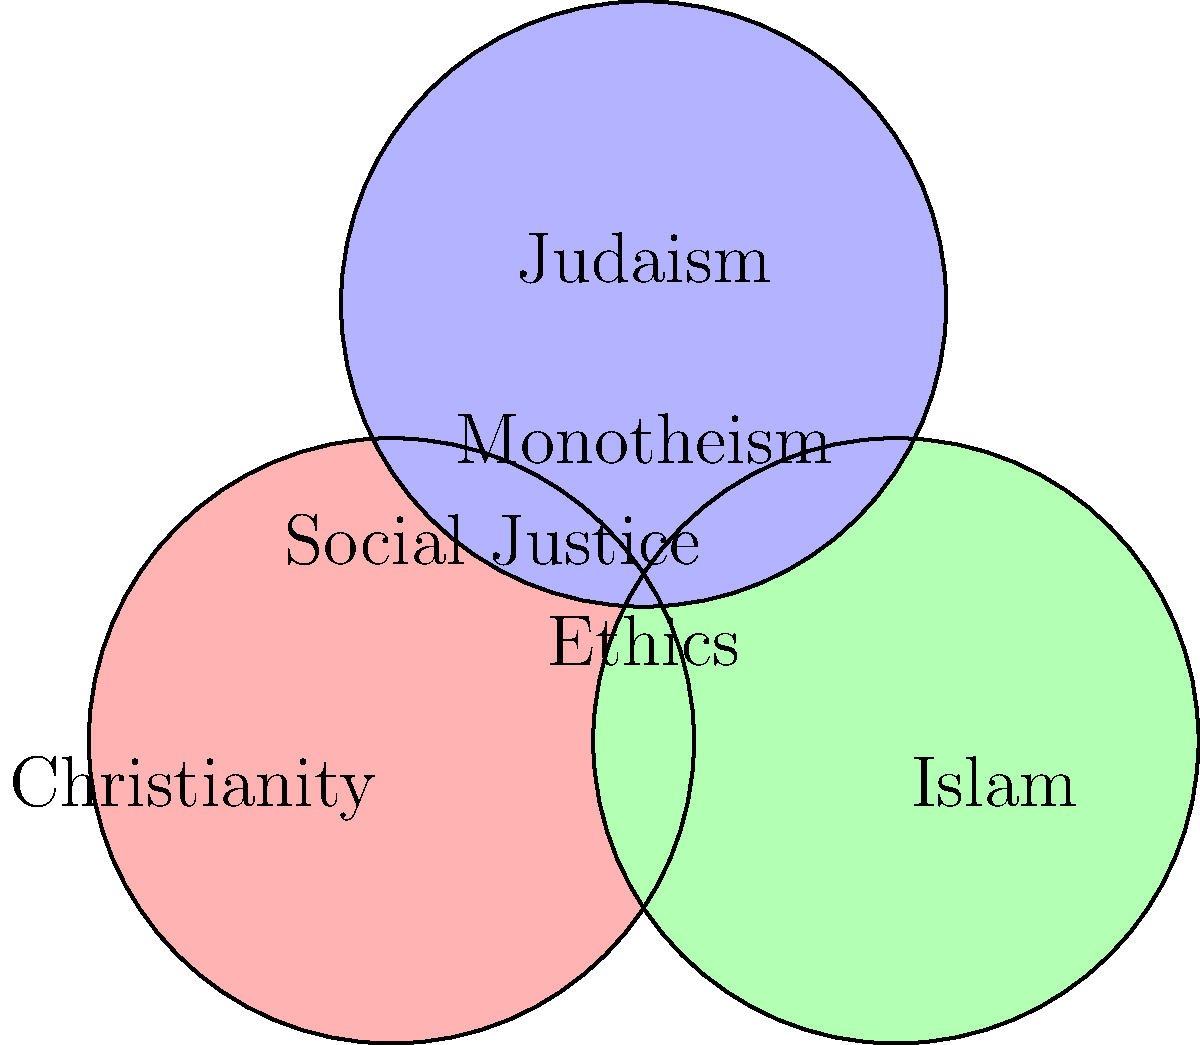In the Venn diagram representing the intersection of Christianity, Islam, and Judaism, which concept is placed at the center, suggesting it is common to all three religions? To answer this question, we need to analyze the Venn diagram step by step:

1. The diagram shows three overlapping circles, each representing one of the three Abrahamic religions: Christianity, Islam, and Judaism.

2. Each circle is labeled with the name of the religion it represents.

3. In the areas where the circles overlap, we can see various concepts that are shared between two or more religions.

4. The area where all three circles intersect represents concepts that are common to all three religions.

5. In this central area, we can see the word "Monotheism" written.

6. Monotheism, the belief in one God, is indeed a fundamental principle shared by Christianity, Islam, and Judaism.

7. Other concepts shown in the diagram, such as "Ethics" and "Social Justice," are also important in these religions but are not placed at the center where all three circles intersect.

Therefore, the concept placed at the center of the Venn diagram, suggesting it is common to all three religions, is Monotheism.
Answer: Monotheism 